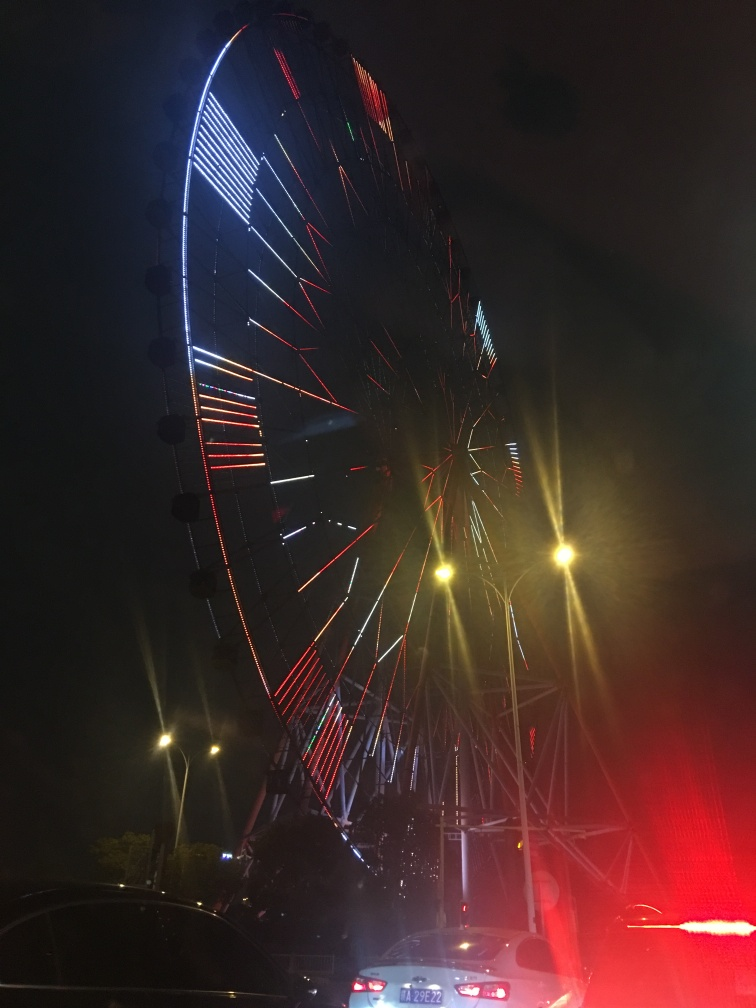Can you describe the pattern of lights on the ferris wheel? The lights on the ferris wheel create a symmetrical pattern with alternating colors of red, white, and blue. The lights are arranged in straight lines radiating from the center of the wheel, and some lights are flashing, giving a dynamic appearance. 